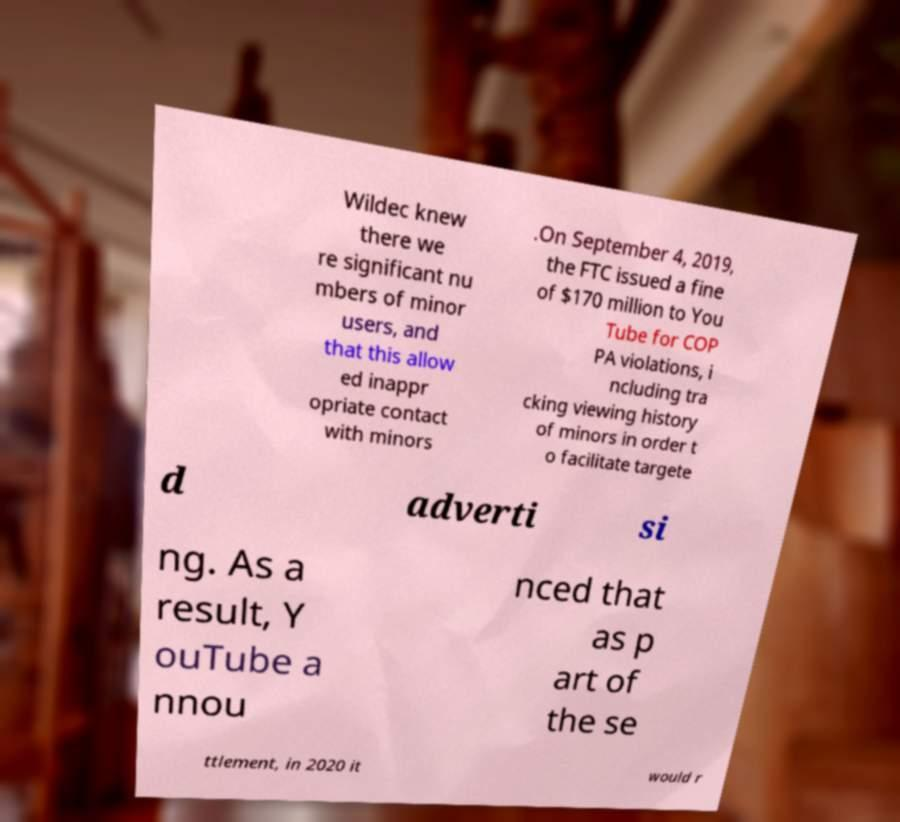Could you assist in decoding the text presented in this image and type it out clearly? Wildec knew there we re significant nu mbers of minor users, and that this allow ed inappr opriate contact with minors .On September 4, 2019, the FTC issued a fine of $170 million to You Tube for COP PA violations, i ncluding tra cking viewing history of minors in order t o facilitate targete d adverti si ng. As a result, Y ouTube a nnou nced that as p art of the se ttlement, in 2020 it would r 